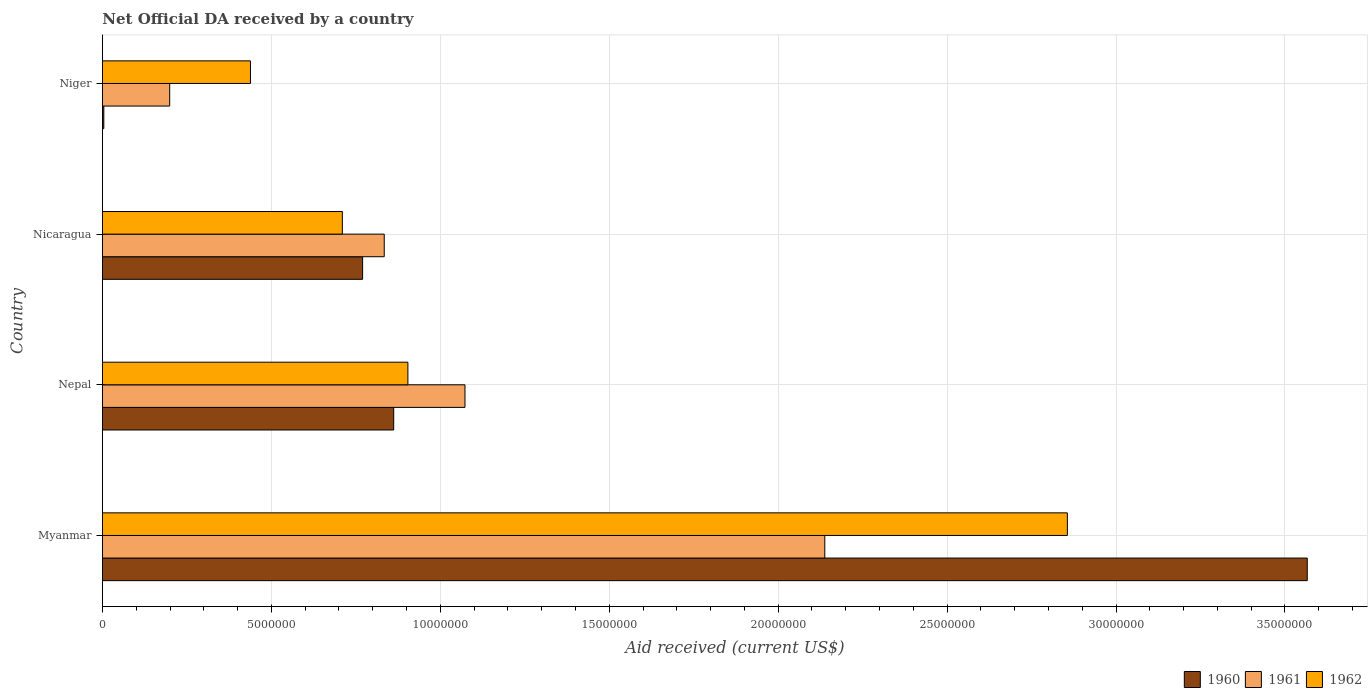How many different coloured bars are there?
Give a very brief answer. 3. How many groups of bars are there?
Make the answer very short. 4. How many bars are there on the 3rd tick from the bottom?
Your response must be concise. 3. What is the label of the 1st group of bars from the top?
Give a very brief answer. Niger. In how many cases, is the number of bars for a given country not equal to the number of legend labels?
Provide a succinct answer. 0. What is the net official development assistance aid received in 1962 in Nepal?
Your response must be concise. 9.04e+06. Across all countries, what is the maximum net official development assistance aid received in 1960?
Give a very brief answer. 3.57e+07. Across all countries, what is the minimum net official development assistance aid received in 1961?
Ensure brevity in your answer.  1.99e+06. In which country was the net official development assistance aid received in 1961 maximum?
Provide a succinct answer. Myanmar. In which country was the net official development assistance aid received in 1960 minimum?
Your response must be concise. Niger. What is the total net official development assistance aid received in 1962 in the graph?
Your response must be concise. 4.91e+07. What is the difference between the net official development assistance aid received in 1962 in Myanmar and that in Nicaragua?
Ensure brevity in your answer.  2.15e+07. What is the difference between the net official development assistance aid received in 1960 in Nicaragua and the net official development assistance aid received in 1961 in Myanmar?
Offer a terse response. -1.37e+07. What is the average net official development assistance aid received in 1961 per country?
Provide a short and direct response. 1.06e+07. What is the difference between the net official development assistance aid received in 1960 and net official development assistance aid received in 1962 in Nepal?
Provide a short and direct response. -4.20e+05. In how many countries, is the net official development assistance aid received in 1960 greater than 23000000 US$?
Provide a succinct answer. 1. What is the ratio of the net official development assistance aid received in 1962 in Myanmar to that in Niger?
Provide a short and direct response. 6.52. Is the net official development assistance aid received in 1962 in Nicaragua less than that in Niger?
Offer a very short reply. No. Is the difference between the net official development assistance aid received in 1960 in Myanmar and Niger greater than the difference between the net official development assistance aid received in 1962 in Myanmar and Niger?
Ensure brevity in your answer.  Yes. What is the difference between the highest and the second highest net official development assistance aid received in 1960?
Your response must be concise. 2.70e+07. What is the difference between the highest and the lowest net official development assistance aid received in 1960?
Make the answer very short. 3.56e+07. In how many countries, is the net official development assistance aid received in 1962 greater than the average net official development assistance aid received in 1962 taken over all countries?
Your answer should be compact. 1. What does the 1st bar from the top in Myanmar represents?
Keep it short and to the point. 1962. What does the 3rd bar from the bottom in Nepal represents?
Keep it short and to the point. 1962. Are the values on the major ticks of X-axis written in scientific E-notation?
Offer a very short reply. No. Does the graph contain grids?
Provide a short and direct response. Yes. How many legend labels are there?
Ensure brevity in your answer.  3. What is the title of the graph?
Make the answer very short. Net Official DA received by a country. Does "1974" appear as one of the legend labels in the graph?
Ensure brevity in your answer.  No. What is the label or title of the X-axis?
Provide a short and direct response. Aid received (current US$). What is the label or title of the Y-axis?
Provide a short and direct response. Country. What is the Aid received (current US$) in 1960 in Myanmar?
Offer a terse response. 3.57e+07. What is the Aid received (current US$) in 1961 in Myanmar?
Your answer should be compact. 2.14e+07. What is the Aid received (current US$) in 1962 in Myanmar?
Provide a succinct answer. 2.86e+07. What is the Aid received (current US$) in 1960 in Nepal?
Ensure brevity in your answer.  8.62e+06. What is the Aid received (current US$) in 1961 in Nepal?
Provide a short and direct response. 1.07e+07. What is the Aid received (current US$) of 1962 in Nepal?
Your response must be concise. 9.04e+06. What is the Aid received (current US$) of 1960 in Nicaragua?
Make the answer very short. 7.70e+06. What is the Aid received (current US$) in 1961 in Nicaragua?
Your response must be concise. 8.34e+06. What is the Aid received (current US$) in 1962 in Nicaragua?
Give a very brief answer. 7.10e+06. What is the Aid received (current US$) in 1960 in Niger?
Provide a succinct answer. 4.00e+04. What is the Aid received (current US$) in 1961 in Niger?
Your answer should be very brief. 1.99e+06. What is the Aid received (current US$) in 1962 in Niger?
Your answer should be very brief. 4.38e+06. Across all countries, what is the maximum Aid received (current US$) in 1960?
Provide a succinct answer. 3.57e+07. Across all countries, what is the maximum Aid received (current US$) in 1961?
Your answer should be compact. 2.14e+07. Across all countries, what is the maximum Aid received (current US$) of 1962?
Keep it short and to the point. 2.86e+07. Across all countries, what is the minimum Aid received (current US$) in 1961?
Offer a terse response. 1.99e+06. Across all countries, what is the minimum Aid received (current US$) in 1962?
Keep it short and to the point. 4.38e+06. What is the total Aid received (current US$) of 1960 in the graph?
Offer a very short reply. 5.20e+07. What is the total Aid received (current US$) in 1961 in the graph?
Provide a short and direct response. 4.24e+07. What is the total Aid received (current US$) of 1962 in the graph?
Provide a short and direct response. 4.91e+07. What is the difference between the Aid received (current US$) in 1960 in Myanmar and that in Nepal?
Provide a succinct answer. 2.70e+07. What is the difference between the Aid received (current US$) in 1961 in Myanmar and that in Nepal?
Make the answer very short. 1.06e+07. What is the difference between the Aid received (current US$) of 1962 in Myanmar and that in Nepal?
Make the answer very short. 1.95e+07. What is the difference between the Aid received (current US$) of 1960 in Myanmar and that in Nicaragua?
Offer a very short reply. 2.80e+07. What is the difference between the Aid received (current US$) of 1961 in Myanmar and that in Nicaragua?
Ensure brevity in your answer.  1.30e+07. What is the difference between the Aid received (current US$) of 1962 in Myanmar and that in Nicaragua?
Give a very brief answer. 2.15e+07. What is the difference between the Aid received (current US$) in 1960 in Myanmar and that in Niger?
Your response must be concise. 3.56e+07. What is the difference between the Aid received (current US$) of 1961 in Myanmar and that in Niger?
Ensure brevity in your answer.  1.94e+07. What is the difference between the Aid received (current US$) in 1962 in Myanmar and that in Niger?
Your answer should be compact. 2.42e+07. What is the difference between the Aid received (current US$) of 1960 in Nepal and that in Nicaragua?
Give a very brief answer. 9.20e+05. What is the difference between the Aid received (current US$) in 1961 in Nepal and that in Nicaragua?
Make the answer very short. 2.39e+06. What is the difference between the Aid received (current US$) of 1962 in Nepal and that in Nicaragua?
Keep it short and to the point. 1.94e+06. What is the difference between the Aid received (current US$) of 1960 in Nepal and that in Niger?
Offer a terse response. 8.58e+06. What is the difference between the Aid received (current US$) in 1961 in Nepal and that in Niger?
Ensure brevity in your answer.  8.74e+06. What is the difference between the Aid received (current US$) in 1962 in Nepal and that in Niger?
Your answer should be compact. 4.66e+06. What is the difference between the Aid received (current US$) in 1960 in Nicaragua and that in Niger?
Provide a short and direct response. 7.66e+06. What is the difference between the Aid received (current US$) of 1961 in Nicaragua and that in Niger?
Your response must be concise. 6.35e+06. What is the difference between the Aid received (current US$) of 1962 in Nicaragua and that in Niger?
Offer a terse response. 2.72e+06. What is the difference between the Aid received (current US$) of 1960 in Myanmar and the Aid received (current US$) of 1961 in Nepal?
Your response must be concise. 2.49e+07. What is the difference between the Aid received (current US$) in 1960 in Myanmar and the Aid received (current US$) in 1962 in Nepal?
Ensure brevity in your answer.  2.66e+07. What is the difference between the Aid received (current US$) in 1961 in Myanmar and the Aid received (current US$) in 1962 in Nepal?
Provide a succinct answer. 1.23e+07. What is the difference between the Aid received (current US$) of 1960 in Myanmar and the Aid received (current US$) of 1961 in Nicaragua?
Keep it short and to the point. 2.73e+07. What is the difference between the Aid received (current US$) in 1960 in Myanmar and the Aid received (current US$) in 1962 in Nicaragua?
Your answer should be very brief. 2.86e+07. What is the difference between the Aid received (current US$) of 1961 in Myanmar and the Aid received (current US$) of 1962 in Nicaragua?
Make the answer very short. 1.43e+07. What is the difference between the Aid received (current US$) in 1960 in Myanmar and the Aid received (current US$) in 1961 in Niger?
Your answer should be compact. 3.37e+07. What is the difference between the Aid received (current US$) in 1960 in Myanmar and the Aid received (current US$) in 1962 in Niger?
Your response must be concise. 3.13e+07. What is the difference between the Aid received (current US$) of 1961 in Myanmar and the Aid received (current US$) of 1962 in Niger?
Make the answer very short. 1.70e+07. What is the difference between the Aid received (current US$) of 1960 in Nepal and the Aid received (current US$) of 1961 in Nicaragua?
Make the answer very short. 2.80e+05. What is the difference between the Aid received (current US$) in 1960 in Nepal and the Aid received (current US$) in 1962 in Nicaragua?
Make the answer very short. 1.52e+06. What is the difference between the Aid received (current US$) of 1961 in Nepal and the Aid received (current US$) of 1962 in Nicaragua?
Ensure brevity in your answer.  3.63e+06. What is the difference between the Aid received (current US$) in 1960 in Nepal and the Aid received (current US$) in 1961 in Niger?
Provide a succinct answer. 6.63e+06. What is the difference between the Aid received (current US$) of 1960 in Nepal and the Aid received (current US$) of 1962 in Niger?
Ensure brevity in your answer.  4.24e+06. What is the difference between the Aid received (current US$) in 1961 in Nepal and the Aid received (current US$) in 1962 in Niger?
Your answer should be compact. 6.35e+06. What is the difference between the Aid received (current US$) of 1960 in Nicaragua and the Aid received (current US$) of 1961 in Niger?
Provide a short and direct response. 5.71e+06. What is the difference between the Aid received (current US$) of 1960 in Nicaragua and the Aid received (current US$) of 1962 in Niger?
Make the answer very short. 3.32e+06. What is the difference between the Aid received (current US$) of 1961 in Nicaragua and the Aid received (current US$) of 1962 in Niger?
Make the answer very short. 3.96e+06. What is the average Aid received (current US$) of 1960 per country?
Your answer should be very brief. 1.30e+07. What is the average Aid received (current US$) in 1961 per country?
Give a very brief answer. 1.06e+07. What is the average Aid received (current US$) of 1962 per country?
Your answer should be compact. 1.23e+07. What is the difference between the Aid received (current US$) in 1960 and Aid received (current US$) in 1961 in Myanmar?
Your response must be concise. 1.43e+07. What is the difference between the Aid received (current US$) of 1960 and Aid received (current US$) of 1962 in Myanmar?
Provide a short and direct response. 7.10e+06. What is the difference between the Aid received (current US$) in 1961 and Aid received (current US$) in 1962 in Myanmar?
Your answer should be very brief. -7.18e+06. What is the difference between the Aid received (current US$) of 1960 and Aid received (current US$) of 1961 in Nepal?
Your response must be concise. -2.11e+06. What is the difference between the Aid received (current US$) in 1960 and Aid received (current US$) in 1962 in Nepal?
Your response must be concise. -4.20e+05. What is the difference between the Aid received (current US$) in 1961 and Aid received (current US$) in 1962 in Nepal?
Offer a terse response. 1.69e+06. What is the difference between the Aid received (current US$) in 1960 and Aid received (current US$) in 1961 in Nicaragua?
Make the answer very short. -6.40e+05. What is the difference between the Aid received (current US$) of 1960 and Aid received (current US$) of 1962 in Nicaragua?
Your response must be concise. 6.00e+05. What is the difference between the Aid received (current US$) of 1961 and Aid received (current US$) of 1962 in Nicaragua?
Offer a very short reply. 1.24e+06. What is the difference between the Aid received (current US$) in 1960 and Aid received (current US$) in 1961 in Niger?
Your answer should be compact. -1.95e+06. What is the difference between the Aid received (current US$) of 1960 and Aid received (current US$) of 1962 in Niger?
Your answer should be very brief. -4.34e+06. What is the difference between the Aid received (current US$) of 1961 and Aid received (current US$) of 1962 in Niger?
Keep it short and to the point. -2.39e+06. What is the ratio of the Aid received (current US$) in 1960 in Myanmar to that in Nepal?
Offer a terse response. 4.14. What is the ratio of the Aid received (current US$) in 1961 in Myanmar to that in Nepal?
Keep it short and to the point. 1.99. What is the ratio of the Aid received (current US$) in 1962 in Myanmar to that in Nepal?
Make the answer very short. 3.16. What is the ratio of the Aid received (current US$) in 1960 in Myanmar to that in Nicaragua?
Provide a succinct answer. 4.63. What is the ratio of the Aid received (current US$) in 1961 in Myanmar to that in Nicaragua?
Make the answer very short. 2.56. What is the ratio of the Aid received (current US$) in 1962 in Myanmar to that in Nicaragua?
Give a very brief answer. 4.02. What is the ratio of the Aid received (current US$) of 1960 in Myanmar to that in Niger?
Your answer should be compact. 891.5. What is the ratio of the Aid received (current US$) of 1961 in Myanmar to that in Niger?
Offer a very short reply. 10.74. What is the ratio of the Aid received (current US$) of 1962 in Myanmar to that in Niger?
Your response must be concise. 6.52. What is the ratio of the Aid received (current US$) in 1960 in Nepal to that in Nicaragua?
Your answer should be very brief. 1.12. What is the ratio of the Aid received (current US$) in 1961 in Nepal to that in Nicaragua?
Offer a very short reply. 1.29. What is the ratio of the Aid received (current US$) of 1962 in Nepal to that in Nicaragua?
Give a very brief answer. 1.27. What is the ratio of the Aid received (current US$) in 1960 in Nepal to that in Niger?
Keep it short and to the point. 215.5. What is the ratio of the Aid received (current US$) of 1961 in Nepal to that in Niger?
Give a very brief answer. 5.39. What is the ratio of the Aid received (current US$) in 1962 in Nepal to that in Niger?
Your response must be concise. 2.06. What is the ratio of the Aid received (current US$) of 1960 in Nicaragua to that in Niger?
Keep it short and to the point. 192.5. What is the ratio of the Aid received (current US$) in 1961 in Nicaragua to that in Niger?
Offer a very short reply. 4.19. What is the ratio of the Aid received (current US$) of 1962 in Nicaragua to that in Niger?
Provide a short and direct response. 1.62. What is the difference between the highest and the second highest Aid received (current US$) of 1960?
Your response must be concise. 2.70e+07. What is the difference between the highest and the second highest Aid received (current US$) of 1961?
Your answer should be compact. 1.06e+07. What is the difference between the highest and the second highest Aid received (current US$) in 1962?
Give a very brief answer. 1.95e+07. What is the difference between the highest and the lowest Aid received (current US$) in 1960?
Provide a short and direct response. 3.56e+07. What is the difference between the highest and the lowest Aid received (current US$) in 1961?
Give a very brief answer. 1.94e+07. What is the difference between the highest and the lowest Aid received (current US$) of 1962?
Your answer should be very brief. 2.42e+07. 